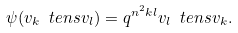Convert formula to latex. <formula><loc_0><loc_0><loc_500><loc_500>\psi ( v _ { k } \ t e n s v _ { l } ) = q ^ { n ^ { 2 } k l } v _ { l } \ t e n s v _ { k } .</formula> 